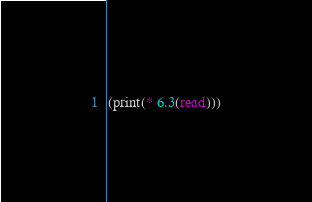Convert code to text. <code><loc_0><loc_0><loc_500><loc_500><_Scheme_>(print(* 6.3(read)))</code> 